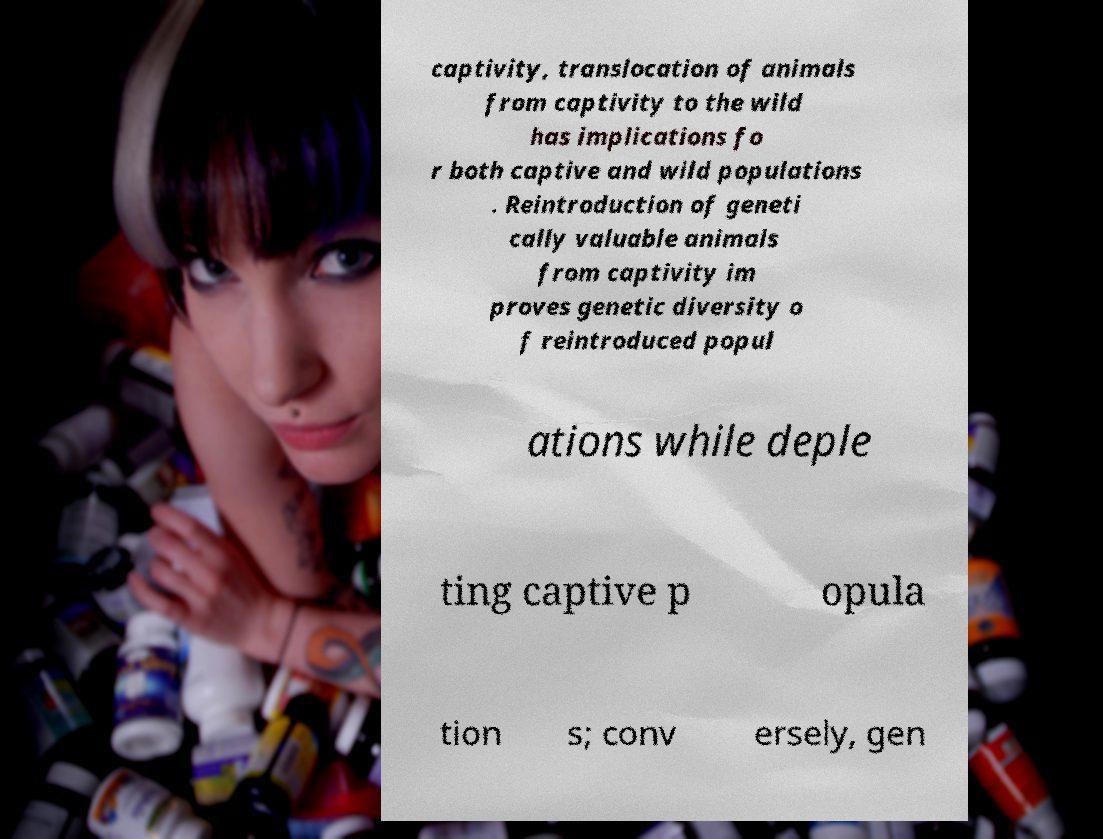Can you read and provide the text displayed in the image?This photo seems to have some interesting text. Can you extract and type it out for me? captivity, translocation of animals from captivity to the wild has implications fo r both captive and wild populations . Reintroduction of geneti cally valuable animals from captivity im proves genetic diversity o f reintroduced popul ations while deple ting captive p opula tion s; conv ersely, gen 